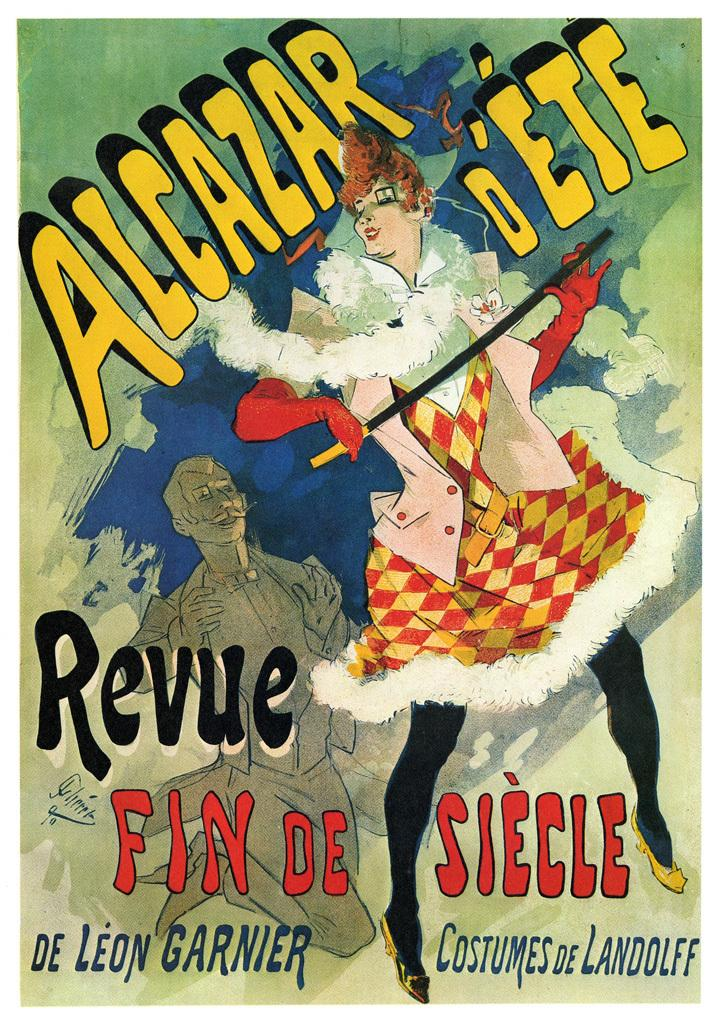<image>
Summarize the visual content of the image. A poster for Alcazar Revue Fin de Siecle. 